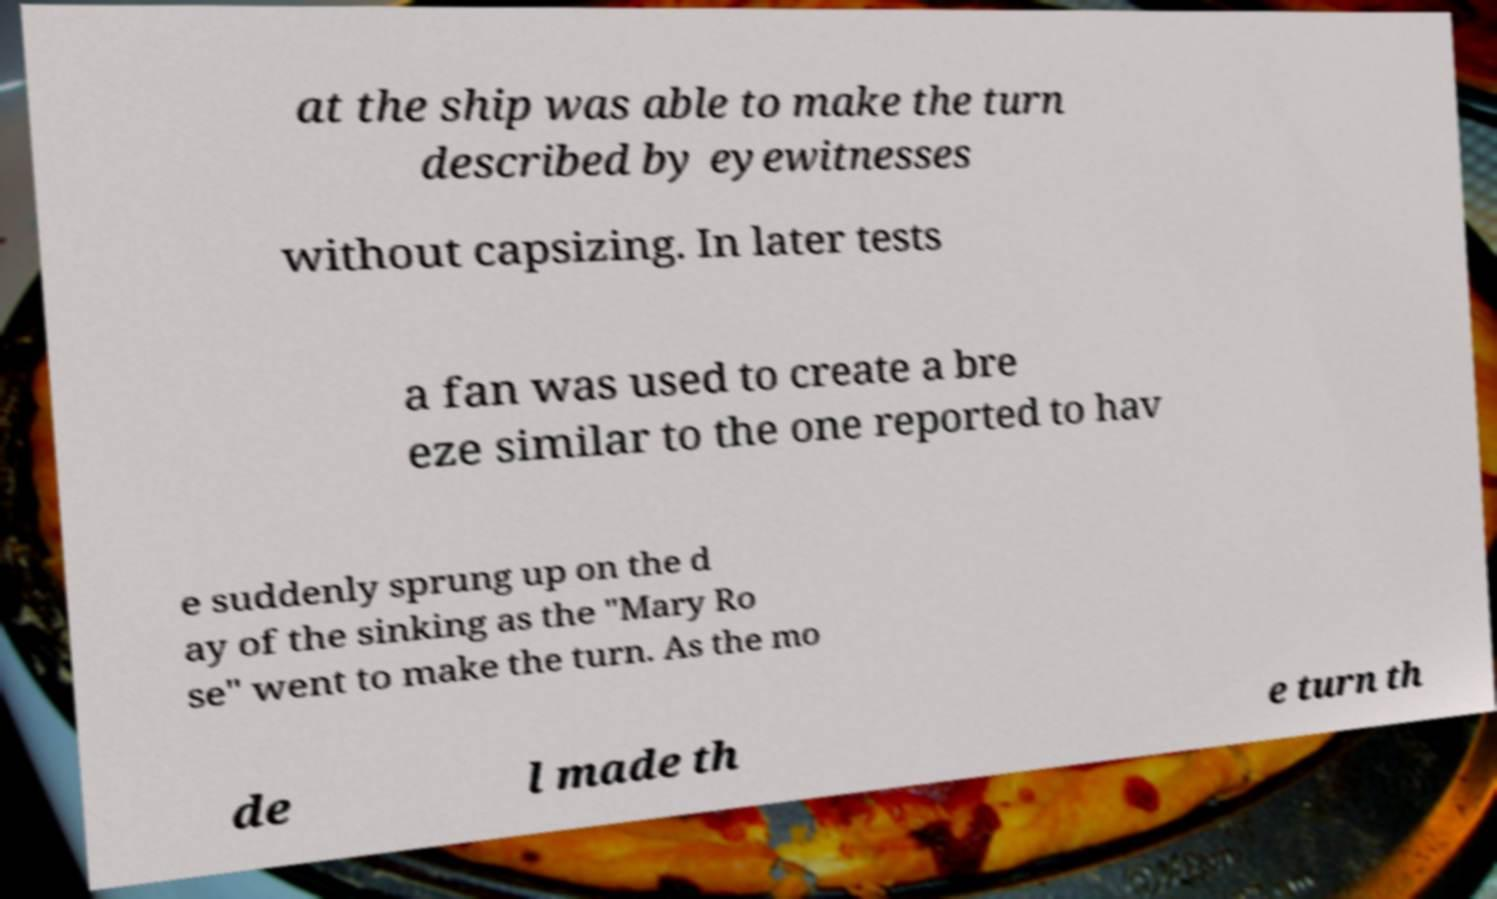Please identify and transcribe the text found in this image. at the ship was able to make the turn described by eyewitnesses without capsizing. In later tests a fan was used to create a bre eze similar to the one reported to hav e suddenly sprung up on the d ay of the sinking as the "Mary Ro se" went to make the turn. As the mo de l made th e turn th 